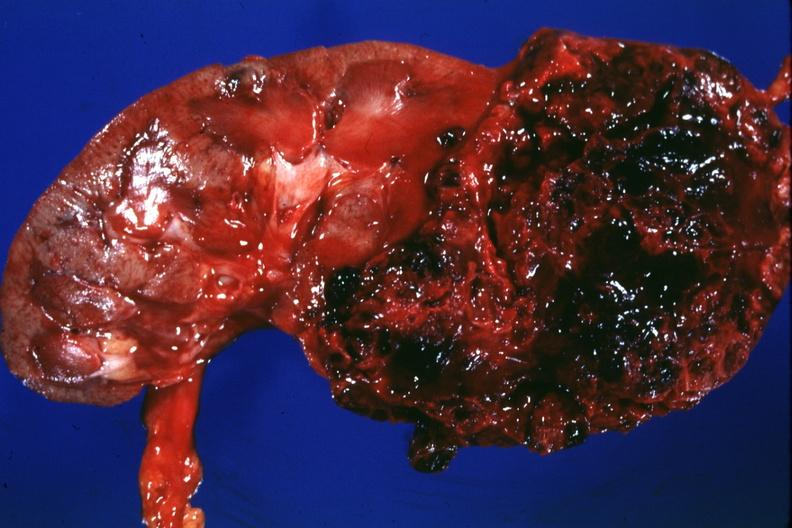does this image show large lesion more hemorrhagic than usual -?
Answer the question using a single word or phrase. Yes 